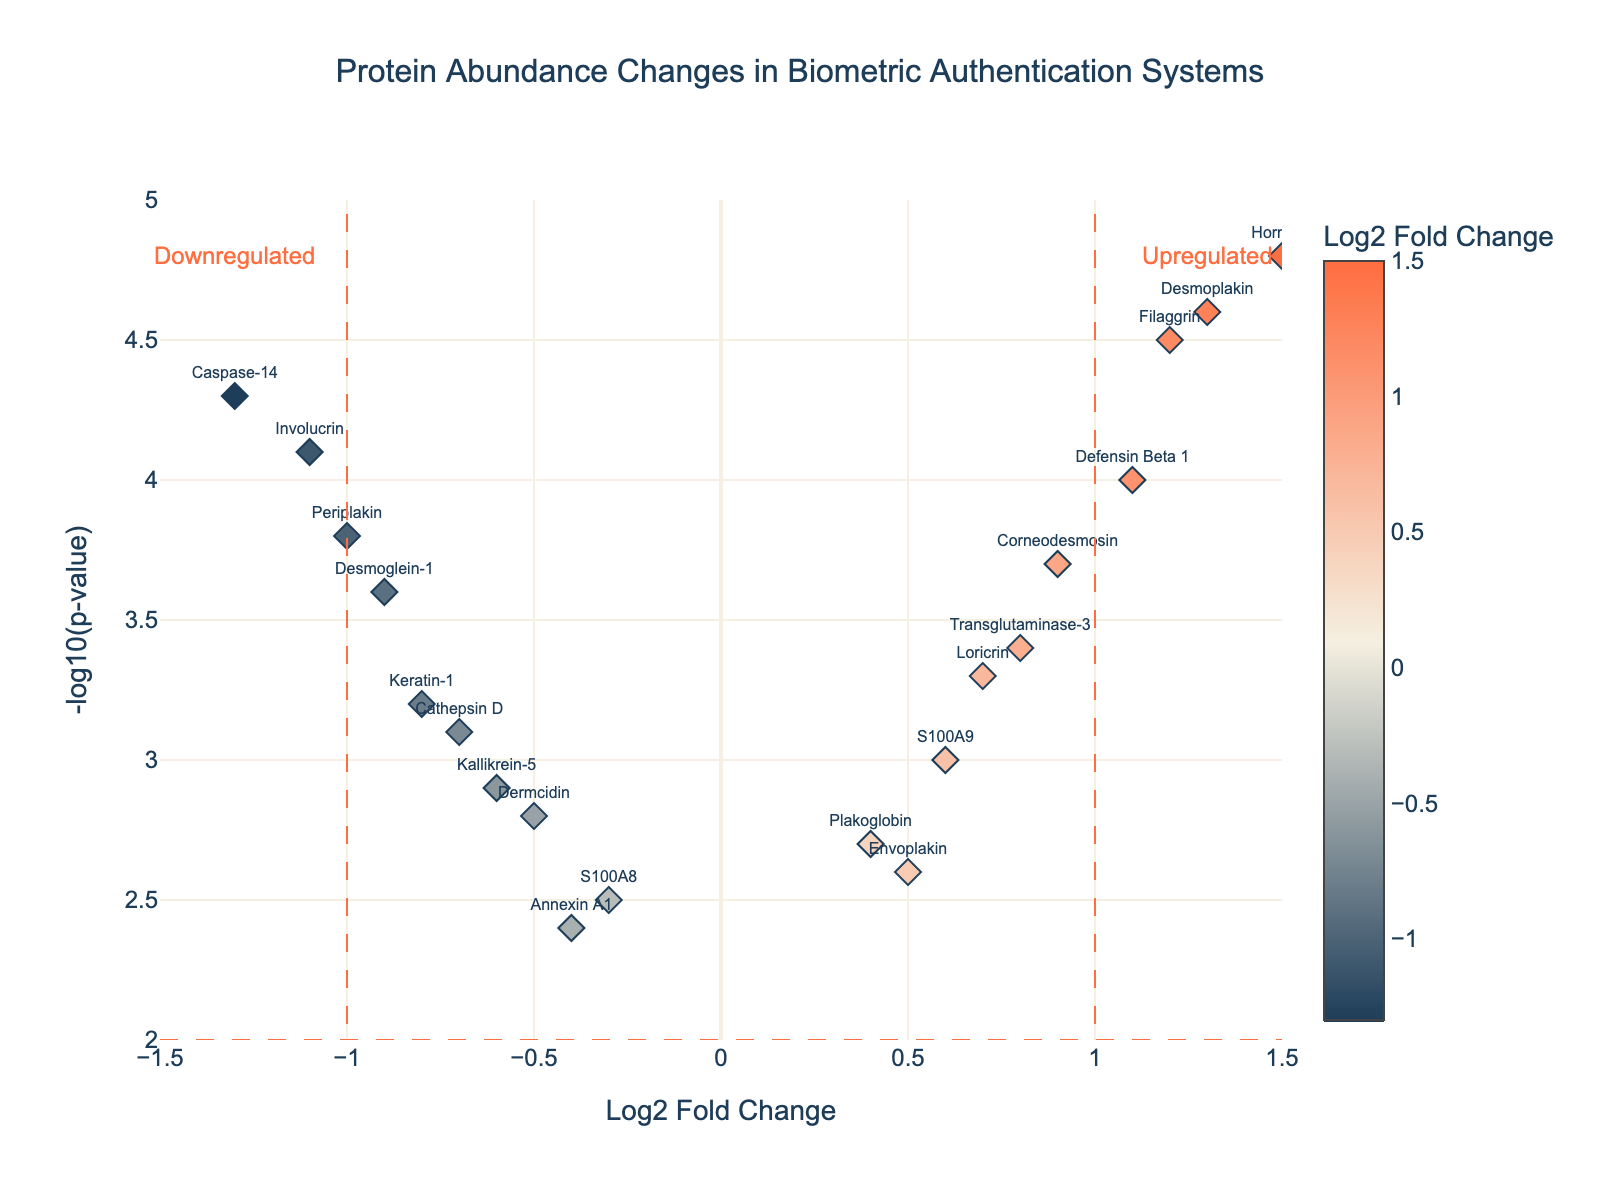How many proteins are represented in the plot? Count the number of data points on the plot. Each protein is represented by a single point.
Answer: 20 What does a positive Log2 Fold Change indicate in this plot? Positive Log2 Fold Change values indicate proteins that are more abundant after the security breach compared to before the breach.
Answer: More abundant after breach Which protein has the highest significance in terms of -log10(p-value)? Look for the protein with the highest y-value in the plot. Hornerin has the highest -log10(p-value) of 4.8.
Answer: Hornerin Which proteins are considered statistically significant and upregulated? Statistically significant proteins have -log10(p-value) > 2 and are color-coded; upregulated proteins have positive Log2 Fold Change indicated primarily by positive x-values. Proteins like Hornerin, Filaggrin, Corneodesmosin, Defensin Beta 1, Desmoplakin are such examples.
Answer: Hornerin, Filaggrin, Corneodesmosin, Defensin Beta 1, Desmoplakin What demarcates the threshold for significance on the x-axis and y-axis? The plot has lines at Log2 Fold Change = ±1 (vertical lines) and -log10(p-value) = 2 (horizontal line) as significance thresholds.
Answer: Log2 Fold Change = ±1, -log10(p-value) = 2 Which protein has the lowest abundance change? Search for the point closest to the y-axis (Log2 Fold Change close to 0). Caspase-14 is one of the proteins with significant low abundance change due to -1.3 on x-axis.
Answer: Caspase-14 Compare Keratin-1 and Annexin A1 regarding their abundance changes and significance. Keratin-1 has a Log2 Fold Change of -0.8 and a -log10(p-value) of 3.2 while Annexin A1 has a Log2 Fold Change of -0.4 and a -log10(p-value) of 2.4. Keratin-1 is more significantly decreased compared to Annexin A1.
Answer: Keratin-1 is more significantly decreased What is the Log2 Fold Change of the protein with an abundance change roughly halfway between the upregulated and downregulated threshold values? Consider the average value of Log2 Fold Change (0) and find the nearest data point, which in this case is S100A8 with a Log2 Fold Change of -0.3.
Answer: S100A8 Are all upregulated proteins statistically significant? Inspect the plot for upregulated proteins (positive Log2 Fold Change) with vertical values over the significance threshold (-log10(p-value) > 2). Only some of the upregulated proteins meet this criteria, such as Hornerin and Filaggrin.
Answer: No Identify a protein that is significantly downregulated and explain its significance visually. Consider a protein with Log2 Fold Change < -1 and -log10(p-value) > 2, e.g., Involucrin. Its significance is visually indicated by its position beyond the threshold lines on both axes.
Answer: Involucrin 